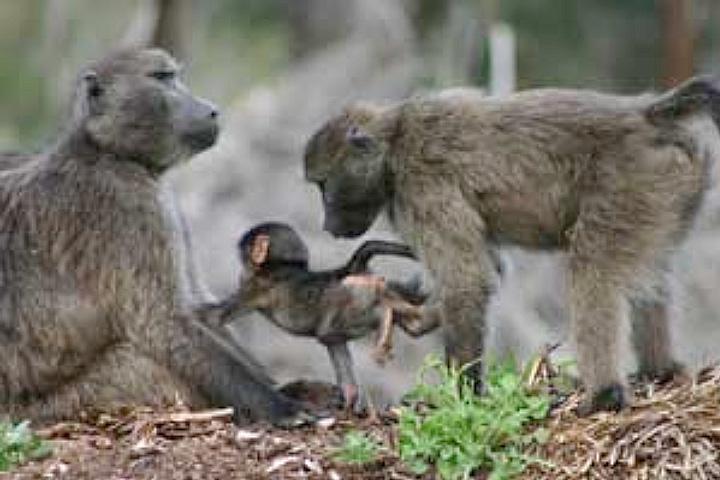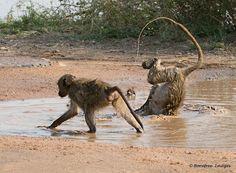The first image is the image on the left, the second image is the image on the right. For the images displayed, is the sentence "The right image contains no more than two monkeys." factually correct? Answer yes or no. Yes. The first image is the image on the left, the second image is the image on the right. Analyze the images presented: Is the assertion "Both images show multiple monkeys in pools of water." valid? Answer yes or no. No. 